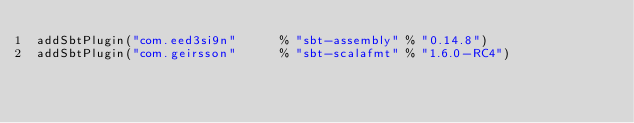Convert code to text. <code><loc_0><loc_0><loc_500><loc_500><_Scala_>addSbtPlugin("com.eed3si9n"      % "sbt-assembly" % "0.14.8")
addSbtPlugin("com.geirsson"      % "sbt-scalafmt" % "1.6.0-RC4")
</code> 